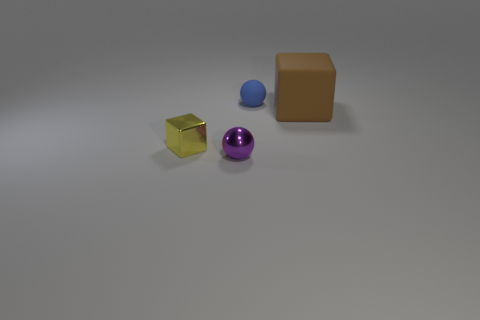Does the small blue rubber object have the same shape as the tiny purple metal object?
Offer a very short reply. Yes. There is a block to the right of the tiny ball in front of the ball that is behind the metal block; how big is it?
Ensure brevity in your answer.  Large. There is a tiny metallic thing on the left side of the purple ball; is there a purple shiny object that is left of it?
Provide a short and direct response. No. How many purple metallic spheres are on the left side of the small ball in front of the cube behind the small yellow object?
Ensure brevity in your answer.  0. What is the color of the object that is in front of the blue matte object and behind the tiny yellow shiny object?
Your answer should be compact. Brown. What number of matte balls are the same color as the large block?
Provide a succinct answer. 0. What number of cylinders are either blue objects or tiny objects?
Provide a short and direct response. 0. There is a metal ball that is the same size as the yellow thing; what color is it?
Offer a very short reply. Purple. Are there any small cubes that are behind the brown rubber thing that is to the right of the tiny object that is in front of the small yellow thing?
Your response must be concise. No. What is the size of the blue matte ball?
Your answer should be compact. Small. 